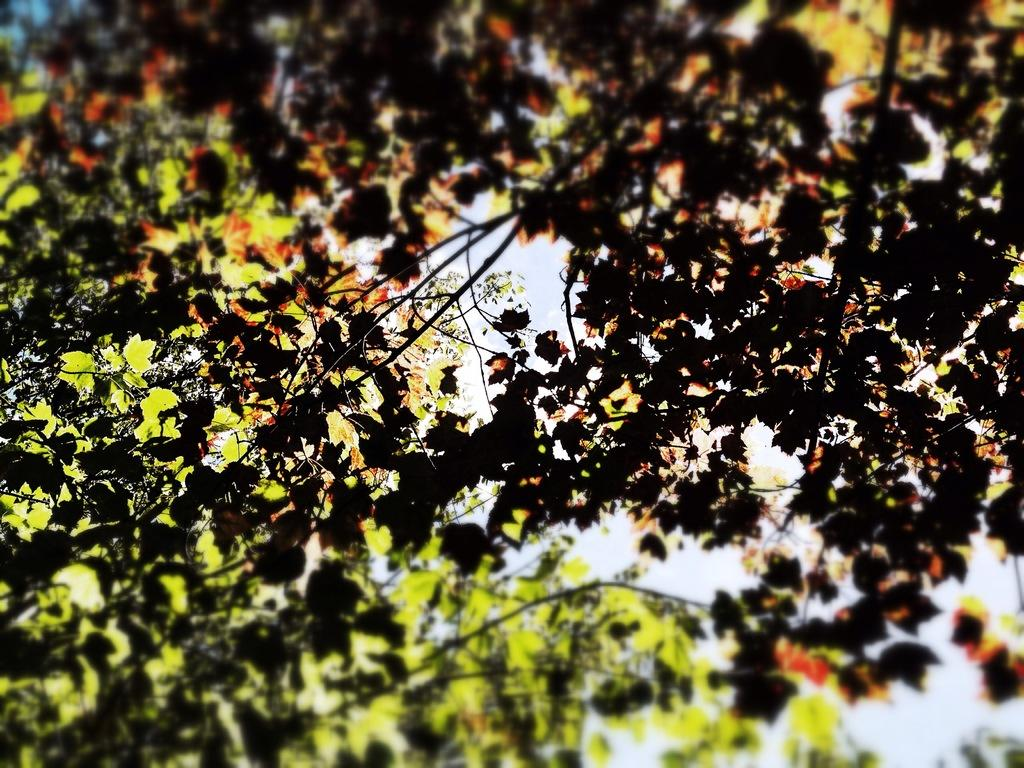What is the focus of the image? The image is a zoomed-in view. What can be seen in the foreground of the image? There are leaves of a tree in the foreground. What is visible in the background of the image? The background of the image includes the sky. What type of skin condition can be seen on the leaves in the image? There is no skin condition present on the leaves in the image, as leaves are part of a plant and do not have skin. 